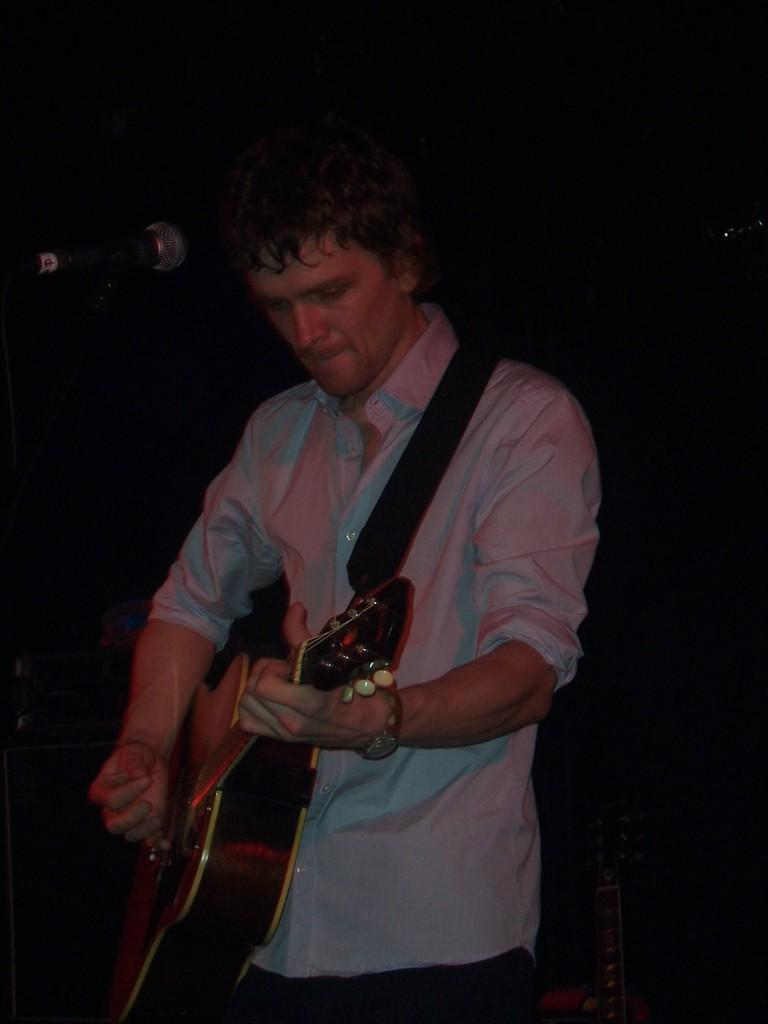Who is the main subject in the image? There is a man in the image. Where is the man positioned in the image? The man is standing in the center of the image. What is the man holding in his hand? The man is holding a guitar in his hand. What is the man doing with the guitar? The man is playing the guitar. What can be seen on the left side of the image? There is a microphone on the left side of the image. What type of whistle is the man using to play the guitar in the image? There is no whistle present in the image; the man is playing the guitar using his hands. 